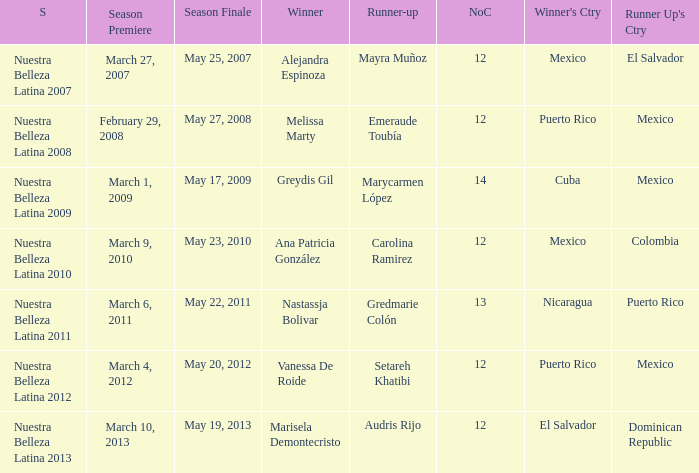How many contestants were there in a season where alejandra espinoza won? 1.0. 